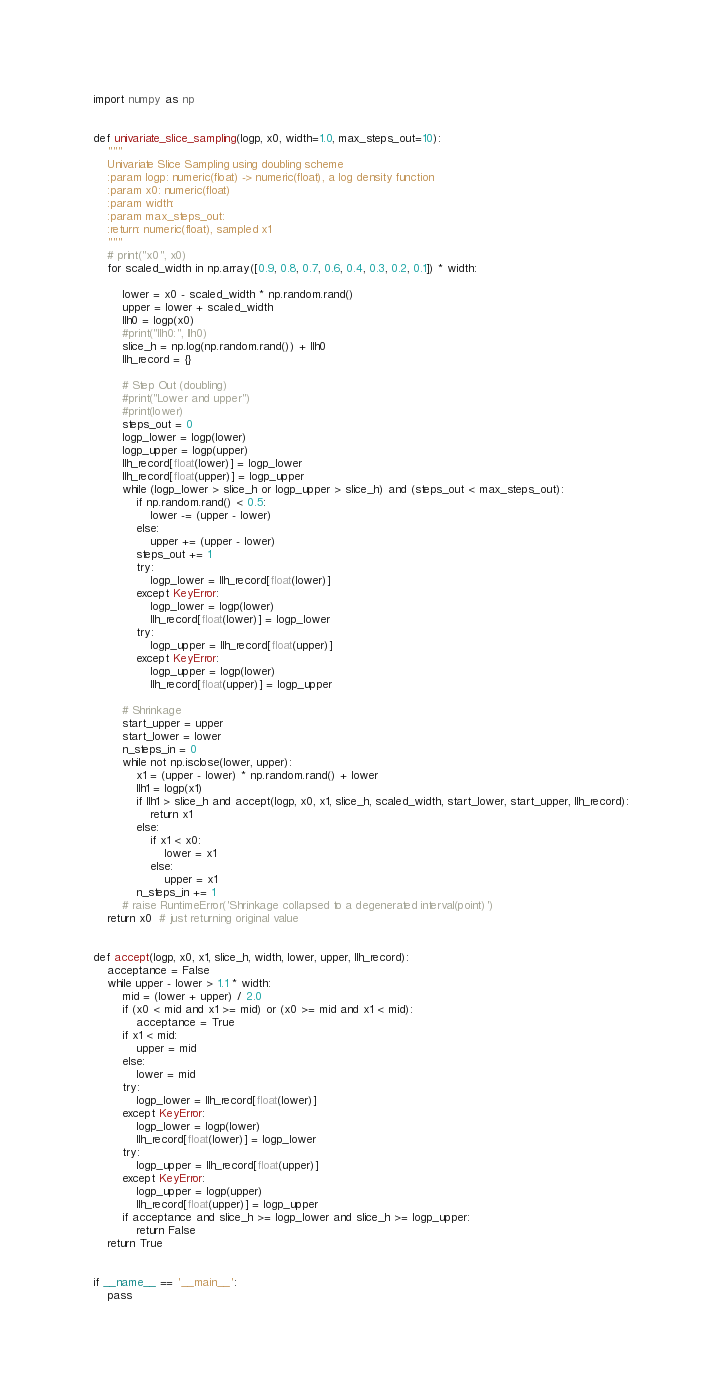<code> <loc_0><loc_0><loc_500><loc_500><_Python_>import numpy as np


def univariate_slice_sampling(logp, x0, width=1.0, max_steps_out=10):
    """
    Univariate Slice Sampling using doubling scheme
    :param logp: numeric(float) -> numeric(float), a log density function
    :param x0: numeric(float)
    :param width:
    :param max_steps_out:
    :return: numeric(float), sampled x1
    """
    # print("x0", x0)
    for scaled_width in np.array([0.9, 0.8, 0.7, 0.6, 0.4, 0.3, 0.2, 0.1]) * width:

        lower = x0 - scaled_width * np.random.rand()
        upper = lower + scaled_width
        llh0 = logp(x0)
        #print("llh0:", llh0)
        slice_h = np.log(np.random.rand()) + llh0
        llh_record = {}

        # Step Out (doubling)
        #print("Lower and upper")
        #print(lower)
        steps_out = 0
        logp_lower = logp(lower)
        logp_upper = logp(upper)
        llh_record[float(lower)] = logp_lower
        llh_record[float(upper)] = logp_upper
        while (logp_lower > slice_h or logp_upper > slice_h) and (steps_out < max_steps_out):
            if np.random.rand() < 0.5:
                lower -= (upper - lower)
            else:
                upper += (upper - lower)
            steps_out += 1
            try:
                logp_lower = llh_record[float(lower)]
            except KeyError:
                logp_lower = logp(lower)
                llh_record[float(lower)] = logp_lower
            try:
                logp_upper = llh_record[float(upper)]
            except KeyError:
                logp_upper = logp(lower)
                llh_record[float(upper)] = logp_upper

        # Shrinkage
        start_upper = upper
        start_lower = lower
        n_steps_in = 0
        while not np.isclose(lower, upper):
            x1 = (upper - lower) * np.random.rand() + lower
            llh1 = logp(x1)
            if llh1 > slice_h and accept(logp, x0, x1, slice_h, scaled_width, start_lower, start_upper, llh_record):
                return x1
            else:
                if x1 < x0:
                    lower = x1
                else:
                    upper = x1
            n_steps_in += 1
        # raise RuntimeError('Shrinkage collapsed to a degenerated interval(point)')
    return x0  # just returning original value


def accept(logp, x0, x1, slice_h, width, lower, upper, llh_record):
    acceptance = False
    while upper - lower > 1.1 * width:
        mid = (lower + upper) / 2.0
        if (x0 < mid and x1 >= mid) or (x0 >= mid and x1 < mid):
            acceptance = True
        if x1 < mid:
            upper = mid
        else:
            lower = mid
        try:
            logp_lower = llh_record[float(lower)]
        except KeyError:
            logp_lower = logp(lower)
            llh_record[float(lower)] = logp_lower
        try:
            logp_upper = llh_record[float(upper)]
        except KeyError:
            logp_upper = logp(upper)
            llh_record[float(upper)] = logp_upper
        if acceptance and slice_h >= logp_lower and slice_h >= logp_upper:
            return False
    return True


if __name__ == '__main__':
    pass</code> 